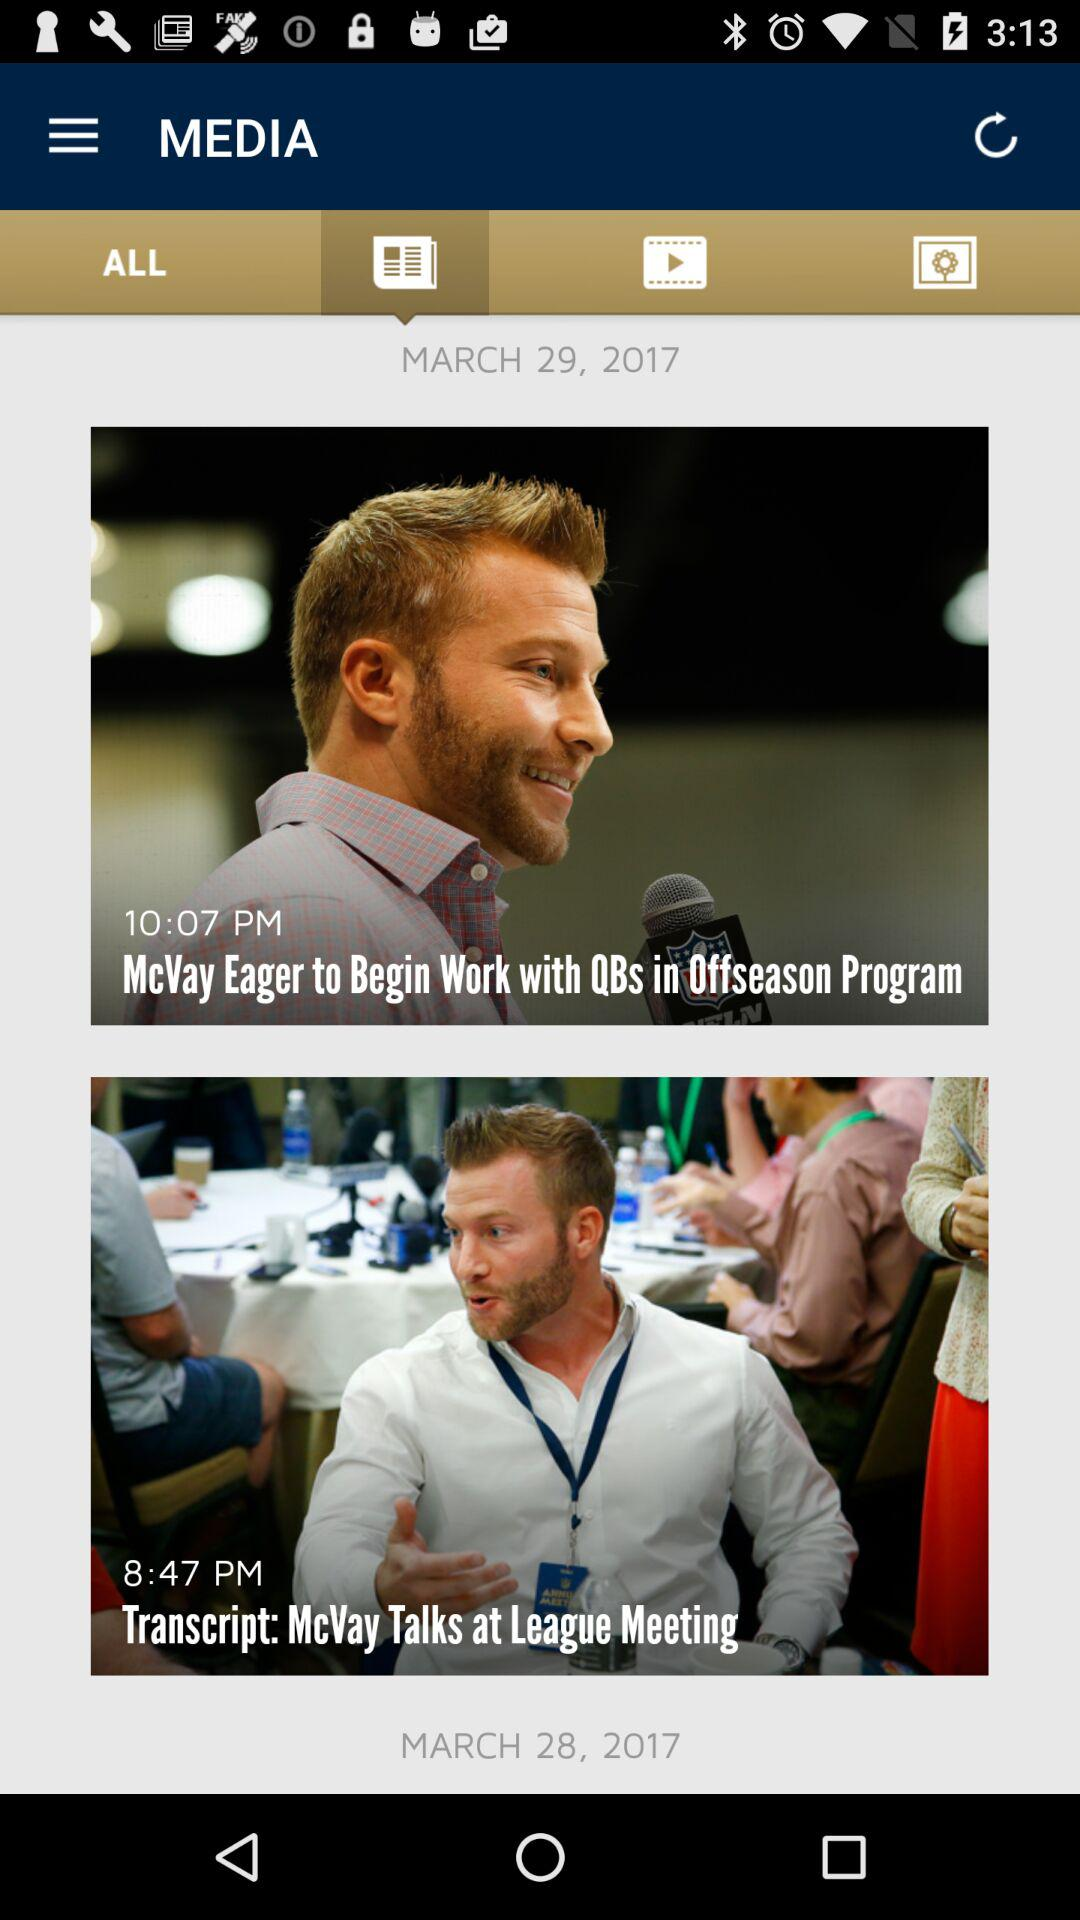How many items are under the McVay header?
Answer the question using a single word or phrase. 2 